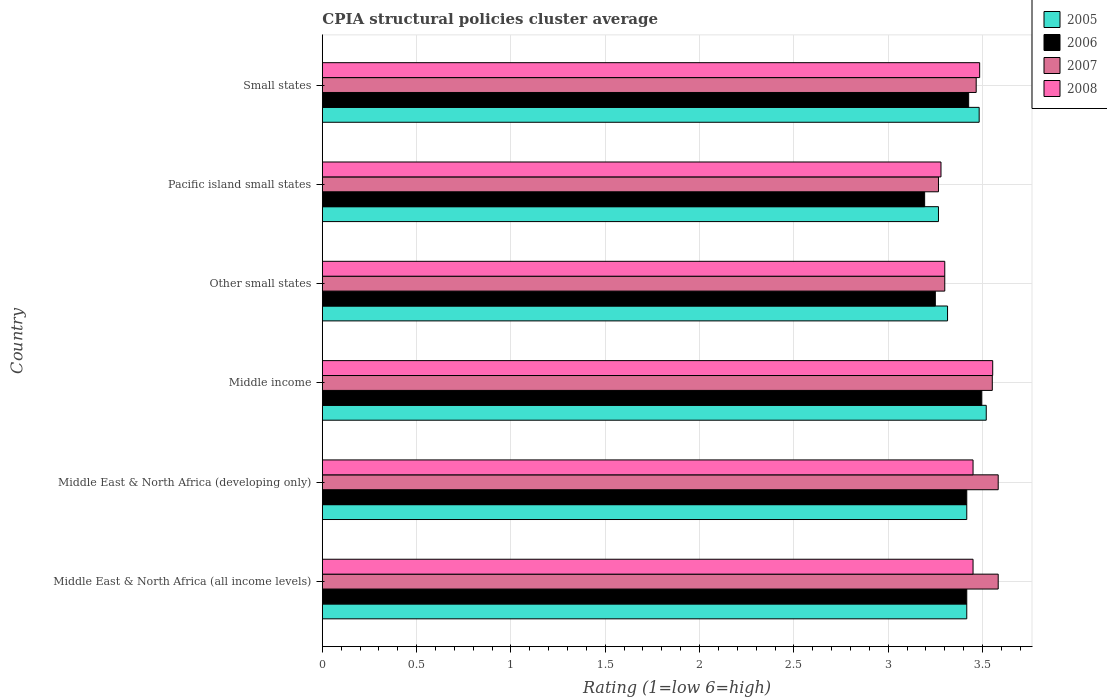How many different coloured bars are there?
Provide a short and direct response. 4. Are the number of bars per tick equal to the number of legend labels?
Keep it short and to the point. Yes. Are the number of bars on each tick of the Y-axis equal?
Your answer should be compact. Yes. How many bars are there on the 6th tick from the top?
Your answer should be compact. 4. How many bars are there on the 4th tick from the bottom?
Provide a succinct answer. 4. What is the CPIA rating in 2005 in Small states?
Your response must be concise. 3.48. Across all countries, what is the maximum CPIA rating in 2008?
Offer a terse response. 3.55. Across all countries, what is the minimum CPIA rating in 2008?
Offer a terse response. 3.28. In which country was the CPIA rating in 2007 maximum?
Your response must be concise. Middle East & North Africa (all income levels). In which country was the CPIA rating in 2008 minimum?
Keep it short and to the point. Pacific island small states. What is the total CPIA rating in 2005 in the graph?
Offer a very short reply. 20.42. What is the difference between the CPIA rating in 2005 in Middle East & North Africa (developing only) and that in Small states?
Keep it short and to the point. -0.07. What is the difference between the CPIA rating in 2006 in Middle East & North Africa (all income levels) and the CPIA rating in 2005 in Middle East & North Africa (developing only)?
Your answer should be very brief. 0. What is the average CPIA rating in 2005 per country?
Offer a very short reply. 3.4. What is the difference between the CPIA rating in 2006 and CPIA rating in 2005 in Small states?
Give a very brief answer. -0.06. What is the ratio of the CPIA rating in 2005 in Middle East & North Africa (developing only) to that in Small states?
Provide a succinct answer. 0.98. Is the CPIA rating in 2007 in Other small states less than that in Pacific island small states?
Give a very brief answer. No. What is the difference between the highest and the second highest CPIA rating in 2006?
Your answer should be compact. 0.07. What is the difference between the highest and the lowest CPIA rating in 2005?
Provide a succinct answer. 0.25. Is it the case that in every country, the sum of the CPIA rating in 2007 and CPIA rating in 2006 is greater than the sum of CPIA rating in 2005 and CPIA rating in 2008?
Your response must be concise. No. What does the 2nd bar from the top in Middle East & North Africa (all income levels) represents?
Make the answer very short. 2007. How many bars are there?
Offer a terse response. 24. Are all the bars in the graph horizontal?
Your response must be concise. Yes. How many countries are there in the graph?
Your answer should be very brief. 6. Are the values on the major ticks of X-axis written in scientific E-notation?
Give a very brief answer. No. Does the graph contain any zero values?
Your answer should be very brief. No. Does the graph contain grids?
Ensure brevity in your answer.  Yes. Where does the legend appear in the graph?
Offer a terse response. Top right. How many legend labels are there?
Provide a short and direct response. 4. How are the legend labels stacked?
Make the answer very short. Vertical. What is the title of the graph?
Keep it short and to the point. CPIA structural policies cluster average. Does "1974" appear as one of the legend labels in the graph?
Keep it short and to the point. No. What is the Rating (1=low 6=high) of 2005 in Middle East & North Africa (all income levels)?
Provide a succinct answer. 3.42. What is the Rating (1=low 6=high) of 2006 in Middle East & North Africa (all income levels)?
Keep it short and to the point. 3.42. What is the Rating (1=low 6=high) in 2007 in Middle East & North Africa (all income levels)?
Your response must be concise. 3.58. What is the Rating (1=low 6=high) of 2008 in Middle East & North Africa (all income levels)?
Provide a short and direct response. 3.45. What is the Rating (1=low 6=high) of 2005 in Middle East & North Africa (developing only)?
Provide a short and direct response. 3.42. What is the Rating (1=low 6=high) in 2006 in Middle East & North Africa (developing only)?
Keep it short and to the point. 3.42. What is the Rating (1=low 6=high) in 2007 in Middle East & North Africa (developing only)?
Your answer should be compact. 3.58. What is the Rating (1=low 6=high) of 2008 in Middle East & North Africa (developing only)?
Make the answer very short. 3.45. What is the Rating (1=low 6=high) in 2005 in Middle income?
Provide a short and direct response. 3.52. What is the Rating (1=low 6=high) of 2006 in Middle income?
Offer a very short reply. 3.5. What is the Rating (1=low 6=high) of 2007 in Middle income?
Your answer should be compact. 3.55. What is the Rating (1=low 6=high) of 2008 in Middle income?
Offer a terse response. 3.55. What is the Rating (1=low 6=high) of 2005 in Other small states?
Keep it short and to the point. 3.31. What is the Rating (1=low 6=high) of 2006 in Other small states?
Offer a terse response. 3.25. What is the Rating (1=low 6=high) of 2008 in Other small states?
Offer a very short reply. 3.3. What is the Rating (1=low 6=high) of 2005 in Pacific island small states?
Provide a short and direct response. 3.27. What is the Rating (1=low 6=high) in 2006 in Pacific island small states?
Ensure brevity in your answer.  3.19. What is the Rating (1=low 6=high) of 2007 in Pacific island small states?
Your answer should be compact. 3.27. What is the Rating (1=low 6=high) in 2008 in Pacific island small states?
Provide a short and direct response. 3.28. What is the Rating (1=low 6=high) in 2005 in Small states?
Provide a succinct answer. 3.48. What is the Rating (1=low 6=high) in 2006 in Small states?
Offer a very short reply. 3.43. What is the Rating (1=low 6=high) in 2007 in Small states?
Ensure brevity in your answer.  3.47. What is the Rating (1=low 6=high) in 2008 in Small states?
Ensure brevity in your answer.  3.48. Across all countries, what is the maximum Rating (1=low 6=high) in 2005?
Provide a succinct answer. 3.52. Across all countries, what is the maximum Rating (1=low 6=high) of 2006?
Your answer should be very brief. 3.5. Across all countries, what is the maximum Rating (1=low 6=high) in 2007?
Provide a short and direct response. 3.58. Across all countries, what is the maximum Rating (1=low 6=high) of 2008?
Provide a short and direct response. 3.55. Across all countries, what is the minimum Rating (1=low 6=high) in 2005?
Give a very brief answer. 3.27. Across all countries, what is the minimum Rating (1=low 6=high) of 2006?
Ensure brevity in your answer.  3.19. Across all countries, what is the minimum Rating (1=low 6=high) of 2007?
Offer a terse response. 3.27. Across all countries, what is the minimum Rating (1=low 6=high) in 2008?
Provide a short and direct response. 3.28. What is the total Rating (1=low 6=high) of 2005 in the graph?
Ensure brevity in your answer.  20.42. What is the total Rating (1=low 6=high) in 2006 in the graph?
Your response must be concise. 20.2. What is the total Rating (1=low 6=high) of 2007 in the graph?
Your answer should be compact. 20.75. What is the total Rating (1=low 6=high) of 2008 in the graph?
Give a very brief answer. 20.52. What is the difference between the Rating (1=low 6=high) in 2005 in Middle East & North Africa (all income levels) and that in Middle East & North Africa (developing only)?
Your answer should be very brief. 0. What is the difference between the Rating (1=low 6=high) of 2006 in Middle East & North Africa (all income levels) and that in Middle East & North Africa (developing only)?
Ensure brevity in your answer.  0. What is the difference between the Rating (1=low 6=high) of 2008 in Middle East & North Africa (all income levels) and that in Middle East & North Africa (developing only)?
Offer a terse response. 0. What is the difference between the Rating (1=low 6=high) in 2005 in Middle East & North Africa (all income levels) and that in Middle income?
Provide a succinct answer. -0.1. What is the difference between the Rating (1=low 6=high) in 2006 in Middle East & North Africa (all income levels) and that in Middle income?
Your answer should be compact. -0.08. What is the difference between the Rating (1=low 6=high) of 2007 in Middle East & North Africa (all income levels) and that in Middle income?
Your answer should be very brief. 0.03. What is the difference between the Rating (1=low 6=high) of 2008 in Middle East & North Africa (all income levels) and that in Middle income?
Give a very brief answer. -0.1. What is the difference between the Rating (1=low 6=high) of 2005 in Middle East & North Africa (all income levels) and that in Other small states?
Your answer should be very brief. 0.1. What is the difference between the Rating (1=low 6=high) of 2007 in Middle East & North Africa (all income levels) and that in Other small states?
Provide a short and direct response. 0.28. What is the difference between the Rating (1=low 6=high) in 2005 in Middle East & North Africa (all income levels) and that in Pacific island small states?
Your answer should be very brief. 0.15. What is the difference between the Rating (1=low 6=high) in 2006 in Middle East & North Africa (all income levels) and that in Pacific island small states?
Give a very brief answer. 0.22. What is the difference between the Rating (1=low 6=high) of 2007 in Middle East & North Africa (all income levels) and that in Pacific island small states?
Give a very brief answer. 0.32. What is the difference between the Rating (1=low 6=high) of 2008 in Middle East & North Africa (all income levels) and that in Pacific island small states?
Offer a terse response. 0.17. What is the difference between the Rating (1=low 6=high) of 2005 in Middle East & North Africa (all income levels) and that in Small states?
Provide a short and direct response. -0.07. What is the difference between the Rating (1=low 6=high) of 2006 in Middle East & North Africa (all income levels) and that in Small states?
Ensure brevity in your answer.  -0.01. What is the difference between the Rating (1=low 6=high) of 2007 in Middle East & North Africa (all income levels) and that in Small states?
Your answer should be compact. 0.12. What is the difference between the Rating (1=low 6=high) in 2008 in Middle East & North Africa (all income levels) and that in Small states?
Keep it short and to the point. -0.04. What is the difference between the Rating (1=low 6=high) of 2005 in Middle East & North Africa (developing only) and that in Middle income?
Give a very brief answer. -0.1. What is the difference between the Rating (1=low 6=high) of 2006 in Middle East & North Africa (developing only) and that in Middle income?
Provide a succinct answer. -0.08. What is the difference between the Rating (1=low 6=high) in 2007 in Middle East & North Africa (developing only) and that in Middle income?
Make the answer very short. 0.03. What is the difference between the Rating (1=low 6=high) of 2008 in Middle East & North Africa (developing only) and that in Middle income?
Your response must be concise. -0.1. What is the difference between the Rating (1=low 6=high) of 2005 in Middle East & North Africa (developing only) and that in Other small states?
Offer a very short reply. 0.1. What is the difference between the Rating (1=low 6=high) in 2007 in Middle East & North Africa (developing only) and that in Other small states?
Offer a very short reply. 0.28. What is the difference between the Rating (1=low 6=high) in 2008 in Middle East & North Africa (developing only) and that in Other small states?
Your answer should be compact. 0.15. What is the difference between the Rating (1=low 6=high) in 2005 in Middle East & North Africa (developing only) and that in Pacific island small states?
Keep it short and to the point. 0.15. What is the difference between the Rating (1=low 6=high) of 2006 in Middle East & North Africa (developing only) and that in Pacific island small states?
Provide a short and direct response. 0.22. What is the difference between the Rating (1=low 6=high) in 2007 in Middle East & North Africa (developing only) and that in Pacific island small states?
Your answer should be very brief. 0.32. What is the difference between the Rating (1=low 6=high) in 2008 in Middle East & North Africa (developing only) and that in Pacific island small states?
Offer a very short reply. 0.17. What is the difference between the Rating (1=low 6=high) of 2005 in Middle East & North Africa (developing only) and that in Small states?
Keep it short and to the point. -0.07. What is the difference between the Rating (1=low 6=high) of 2006 in Middle East & North Africa (developing only) and that in Small states?
Provide a succinct answer. -0.01. What is the difference between the Rating (1=low 6=high) of 2007 in Middle East & North Africa (developing only) and that in Small states?
Ensure brevity in your answer.  0.12. What is the difference between the Rating (1=low 6=high) of 2008 in Middle East & North Africa (developing only) and that in Small states?
Your response must be concise. -0.04. What is the difference between the Rating (1=low 6=high) of 2005 in Middle income and that in Other small states?
Your response must be concise. 0.21. What is the difference between the Rating (1=low 6=high) in 2006 in Middle income and that in Other small states?
Give a very brief answer. 0.25. What is the difference between the Rating (1=low 6=high) of 2007 in Middle income and that in Other small states?
Offer a terse response. 0.25. What is the difference between the Rating (1=low 6=high) in 2008 in Middle income and that in Other small states?
Offer a very short reply. 0.25. What is the difference between the Rating (1=low 6=high) of 2005 in Middle income and that in Pacific island small states?
Your response must be concise. 0.25. What is the difference between the Rating (1=low 6=high) in 2006 in Middle income and that in Pacific island small states?
Give a very brief answer. 0.3. What is the difference between the Rating (1=low 6=high) of 2007 in Middle income and that in Pacific island small states?
Keep it short and to the point. 0.29. What is the difference between the Rating (1=low 6=high) in 2008 in Middle income and that in Pacific island small states?
Your response must be concise. 0.27. What is the difference between the Rating (1=low 6=high) of 2005 in Middle income and that in Small states?
Give a very brief answer. 0.04. What is the difference between the Rating (1=low 6=high) of 2006 in Middle income and that in Small states?
Offer a very short reply. 0.07. What is the difference between the Rating (1=low 6=high) in 2007 in Middle income and that in Small states?
Give a very brief answer. 0.09. What is the difference between the Rating (1=low 6=high) of 2008 in Middle income and that in Small states?
Make the answer very short. 0.07. What is the difference between the Rating (1=low 6=high) of 2005 in Other small states and that in Pacific island small states?
Your response must be concise. 0.05. What is the difference between the Rating (1=low 6=high) of 2006 in Other small states and that in Pacific island small states?
Keep it short and to the point. 0.06. What is the difference between the Rating (1=low 6=high) of 2005 in Other small states and that in Small states?
Keep it short and to the point. -0.17. What is the difference between the Rating (1=low 6=high) in 2006 in Other small states and that in Small states?
Give a very brief answer. -0.18. What is the difference between the Rating (1=low 6=high) of 2007 in Other small states and that in Small states?
Give a very brief answer. -0.17. What is the difference between the Rating (1=low 6=high) of 2008 in Other small states and that in Small states?
Provide a succinct answer. -0.18. What is the difference between the Rating (1=low 6=high) of 2005 in Pacific island small states and that in Small states?
Provide a succinct answer. -0.22. What is the difference between the Rating (1=low 6=high) of 2006 in Pacific island small states and that in Small states?
Provide a succinct answer. -0.23. What is the difference between the Rating (1=low 6=high) of 2008 in Pacific island small states and that in Small states?
Keep it short and to the point. -0.2. What is the difference between the Rating (1=low 6=high) of 2005 in Middle East & North Africa (all income levels) and the Rating (1=low 6=high) of 2006 in Middle East & North Africa (developing only)?
Ensure brevity in your answer.  0. What is the difference between the Rating (1=low 6=high) in 2005 in Middle East & North Africa (all income levels) and the Rating (1=low 6=high) in 2008 in Middle East & North Africa (developing only)?
Offer a terse response. -0.03. What is the difference between the Rating (1=low 6=high) of 2006 in Middle East & North Africa (all income levels) and the Rating (1=low 6=high) of 2007 in Middle East & North Africa (developing only)?
Your response must be concise. -0.17. What is the difference between the Rating (1=low 6=high) of 2006 in Middle East & North Africa (all income levels) and the Rating (1=low 6=high) of 2008 in Middle East & North Africa (developing only)?
Provide a succinct answer. -0.03. What is the difference between the Rating (1=low 6=high) of 2007 in Middle East & North Africa (all income levels) and the Rating (1=low 6=high) of 2008 in Middle East & North Africa (developing only)?
Keep it short and to the point. 0.13. What is the difference between the Rating (1=low 6=high) of 2005 in Middle East & North Africa (all income levels) and the Rating (1=low 6=high) of 2006 in Middle income?
Your answer should be compact. -0.08. What is the difference between the Rating (1=low 6=high) of 2005 in Middle East & North Africa (all income levels) and the Rating (1=low 6=high) of 2007 in Middle income?
Your response must be concise. -0.14. What is the difference between the Rating (1=low 6=high) of 2005 in Middle East & North Africa (all income levels) and the Rating (1=low 6=high) of 2008 in Middle income?
Give a very brief answer. -0.14. What is the difference between the Rating (1=low 6=high) of 2006 in Middle East & North Africa (all income levels) and the Rating (1=low 6=high) of 2007 in Middle income?
Give a very brief answer. -0.14. What is the difference between the Rating (1=low 6=high) in 2006 in Middle East & North Africa (all income levels) and the Rating (1=low 6=high) in 2008 in Middle income?
Provide a short and direct response. -0.14. What is the difference between the Rating (1=low 6=high) of 2007 in Middle East & North Africa (all income levels) and the Rating (1=low 6=high) of 2008 in Middle income?
Provide a short and direct response. 0.03. What is the difference between the Rating (1=low 6=high) of 2005 in Middle East & North Africa (all income levels) and the Rating (1=low 6=high) of 2007 in Other small states?
Provide a short and direct response. 0.12. What is the difference between the Rating (1=low 6=high) of 2005 in Middle East & North Africa (all income levels) and the Rating (1=low 6=high) of 2008 in Other small states?
Your answer should be compact. 0.12. What is the difference between the Rating (1=low 6=high) in 2006 in Middle East & North Africa (all income levels) and the Rating (1=low 6=high) in 2007 in Other small states?
Keep it short and to the point. 0.12. What is the difference between the Rating (1=low 6=high) of 2006 in Middle East & North Africa (all income levels) and the Rating (1=low 6=high) of 2008 in Other small states?
Keep it short and to the point. 0.12. What is the difference between the Rating (1=low 6=high) of 2007 in Middle East & North Africa (all income levels) and the Rating (1=low 6=high) of 2008 in Other small states?
Provide a short and direct response. 0.28. What is the difference between the Rating (1=low 6=high) in 2005 in Middle East & North Africa (all income levels) and the Rating (1=low 6=high) in 2006 in Pacific island small states?
Provide a short and direct response. 0.22. What is the difference between the Rating (1=low 6=high) of 2005 in Middle East & North Africa (all income levels) and the Rating (1=low 6=high) of 2007 in Pacific island small states?
Give a very brief answer. 0.15. What is the difference between the Rating (1=low 6=high) in 2005 in Middle East & North Africa (all income levels) and the Rating (1=low 6=high) in 2008 in Pacific island small states?
Provide a short and direct response. 0.14. What is the difference between the Rating (1=low 6=high) in 2006 in Middle East & North Africa (all income levels) and the Rating (1=low 6=high) in 2008 in Pacific island small states?
Your answer should be very brief. 0.14. What is the difference between the Rating (1=low 6=high) of 2007 in Middle East & North Africa (all income levels) and the Rating (1=low 6=high) of 2008 in Pacific island small states?
Give a very brief answer. 0.3. What is the difference between the Rating (1=low 6=high) in 2005 in Middle East & North Africa (all income levels) and the Rating (1=low 6=high) in 2006 in Small states?
Offer a terse response. -0.01. What is the difference between the Rating (1=low 6=high) in 2005 in Middle East & North Africa (all income levels) and the Rating (1=low 6=high) in 2007 in Small states?
Provide a short and direct response. -0.05. What is the difference between the Rating (1=low 6=high) of 2005 in Middle East & North Africa (all income levels) and the Rating (1=low 6=high) of 2008 in Small states?
Keep it short and to the point. -0.07. What is the difference between the Rating (1=low 6=high) of 2006 in Middle East & North Africa (all income levels) and the Rating (1=low 6=high) of 2008 in Small states?
Ensure brevity in your answer.  -0.07. What is the difference between the Rating (1=low 6=high) in 2007 in Middle East & North Africa (all income levels) and the Rating (1=low 6=high) in 2008 in Small states?
Give a very brief answer. 0.1. What is the difference between the Rating (1=low 6=high) of 2005 in Middle East & North Africa (developing only) and the Rating (1=low 6=high) of 2006 in Middle income?
Ensure brevity in your answer.  -0.08. What is the difference between the Rating (1=low 6=high) in 2005 in Middle East & North Africa (developing only) and the Rating (1=low 6=high) in 2007 in Middle income?
Give a very brief answer. -0.14. What is the difference between the Rating (1=low 6=high) of 2005 in Middle East & North Africa (developing only) and the Rating (1=low 6=high) of 2008 in Middle income?
Give a very brief answer. -0.14. What is the difference between the Rating (1=low 6=high) in 2006 in Middle East & North Africa (developing only) and the Rating (1=low 6=high) in 2007 in Middle income?
Offer a terse response. -0.14. What is the difference between the Rating (1=low 6=high) of 2006 in Middle East & North Africa (developing only) and the Rating (1=low 6=high) of 2008 in Middle income?
Offer a terse response. -0.14. What is the difference between the Rating (1=low 6=high) of 2007 in Middle East & North Africa (developing only) and the Rating (1=low 6=high) of 2008 in Middle income?
Ensure brevity in your answer.  0.03. What is the difference between the Rating (1=low 6=high) of 2005 in Middle East & North Africa (developing only) and the Rating (1=low 6=high) of 2006 in Other small states?
Provide a succinct answer. 0.17. What is the difference between the Rating (1=low 6=high) of 2005 in Middle East & North Africa (developing only) and the Rating (1=low 6=high) of 2007 in Other small states?
Your answer should be compact. 0.12. What is the difference between the Rating (1=low 6=high) of 2005 in Middle East & North Africa (developing only) and the Rating (1=low 6=high) of 2008 in Other small states?
Offer a terse response. 0.12. What is the difference between the Rating (1=low 6=high) of 2006 in Middle East & North Africa (developing only) and the Rating (1=low 6=high) of 2007 in Other small states?
Provide a succinct answer. 0.12. What is the difference between the Rating (1=low 6=high) of 2006 in Middle East & North Africa (developing only) and the Rating (1=low 6=high) of 2008 in Other small states?
Your answer should be very brief. 0.12. What is the difference between the Rating (1=low 6=high) in 2007 in Middle East & North Africa (developing only) and the Rating (1=low 6=high) in 2008 in Other small states?
Your answer should be very brief. 0.28. What is the difference between the Rating (1=low 6=high) of 2005 in Middle East & North Africa (developing only) and the Rating (1=low 6=high) of 2006 in Pacific island small states?
Ensure brevity in your answer.  0.22. What is the difference between the Rating (1=low 6=high) of 2005 in Middle East & North Africa (developing only) and the Rating (1=low 6=high) of 2007 in Pacific island small states?
Make the answer very short. 0.15. What is the difference between the Rating (1=low 6=high) of 2005 in Middle East & North Africa (developing only) and the Rating (1=low 6=high) of 2008 in Pacific island small states?
Your answer should be very brief. 0.14. What is the difference between the Rating (1=low 6=high) of 2006 in Middle East & North Africa (developing only) and the Rating (1=low 6=high) of 2008 in Pacific island small states?
Keep it short and to the point. 0.14. What is the difference between the Rating (1=low 6=high) in 2007 in Middle East & North Africa (developing only) and the Rating (1=low 6=high) in 2008 in Pacific island small states?
Your response must be concise. 0.3. What is the difference between the Rating (1=low 6=high) in 2005 in Middle East & North Africa (developing only) and the Rating (1=low 6=high) in 2006 in Small states?
Offer a very short reply. -0.01. What is the difference between the Rating (1=low 6=high) of 2005 in Middle East & North Africa (developing only) and the Rating (1=low 6=high) of 2007 in Small states?
Your response must be concise. -0.05. What is the difference between the Rating (1=low 6=high) of 2005 in Middle East & North Africa (developing only) and the Rating (1=low 6=high) of 2008 in Small states?
Provide a succinct answer. -0.07. What is the difference between the Rating (1=low 6=high) in 2006 in Middle East & North Africa (developing only) and the Rating (1=low 6=high) in 2008 in Small states?
Your answer should be compact. -0.07. What is the difference between the Rating (1=low 6=high) of 2007 in Middle East & North Africa (developing only) and the Rating (1=low 6=high) of 2008 in Small states?
Provide a short and direct response. 0.1. What is the difference between the Rating (1=low 6=high) of 2005 in Middle income and the Rating (1=low 6=high) of 2006 in Other small states?
Provide a short and direct response. 0.27. What is the difference between the Rating (1=low 6=high) in 2005 in Middle income and the Rating (1=low 6=high) in 2007 in Other small states?
Your answer should be very brief. 0.22. What is the difference between the Rating (1=low 6=high) in 2005 in Middle income and the Rating (1=low 6=high) in 2008 in Other small states?
Provide a succinct answer. 0.22. What is the difference between the Rating (1=low 6=high) in 2006 in Middle income and the Rating (1=low 6=high) in 2007 in Other small states?
Ensure brevity in your answer.  0.2. What is the difference between the Rating (1=low 6=high) in 2006 in Middle income and the Rating (1=low 6=high) in 2008 in Other small states?
Your answer should be compact. 0.2. What is the difference between the Rating (1=low 6=high) in 2007 in Middle income and the Rating (1=low 6=high) in 2008 in Other small states?
Give a very brief answer. 0.25. What is the difference between the Rating (1=low 6=high) in 2005 in Middle income and the Rating (1=low 6=high) in 2006 in Pacific island small states?
Offer a terse response. 0.33. What is the difference between the Rating (1=low 6=high) of 2005 in Middle income and the Rating (1=low 6=high) of 2007 in Pacific island small states?
Ensure brevity in your answer.  0.25. What is the difference between the Rating (1=low 6=high) of 2005 in Middle income and the Rating (1=low 6=high) of 2008 in Pacific island small states?
Make the answer very short. 0.24. What is the difference between the Rating (1=low 6=high) in 2006 in Middle income and the Rating (1=low 6=high) in 2007 in Pacific island small states?
Your answer should be compact. 0.23. What is the difference between the Rating (1=low 6=high) in 2006 in Middle income and the Rating (1=low 6=high) in 2008 in Pacific island small states?
Offer a very short reply. 0.22. What is the difference between the Rating (1=low 6=high) of 2007 in Middle income and the Rating (1=low 6=high) of 2008 in Pacific island small states?
Offer a very short reply. 0.27. What is the difference between the Rating (1=low 6=high) of 2005 in Middle income and the Rating (1=low 6=high) of 2006 in Small states?
Offer a terse response. 0.09. What is the difference between the Rating (1=low 6=high) in 2005 in Middle income and the Rating (1=low 6=high) in 2007 in Small states?
Your answer should be compact. 0.05. What is the difference between the Rating (1=low 6=high) of 2005 in Middle income and the Rating (1=low 6=high) of 2008 in Small states?
Your answer should be very brief. 0.04. What is the difference between the Rating (1=low 6=high) in 2006 in Middle income and the Rating (1=low 6=high) in 2007 in Small states?
Your answer should be very brief. 0.03. What is the difference between the Rating (1=low 6=high) of 2006 in Middle income and the Rating (1=low 6=high) of 2008 in Small states?
Your response must be concise. 0.01. What is the difference between the Rating (1=low 6=high) in 2007 in Middle income and the Rating (1=low 6=high) in 2008 in Small states?
Provide a short and direct response. 0.07. What is the difference between the Rating (1=low 6=high) in 2005 in Other small states and the Rating (1=low 6=high) in 2006 in Pacific island small states?
Give a very brief answer. 0.12. What is the difference between the Rating (1=low 6=high) in 2005 in Other small states and the Rating (1=low 6=high) in 2007 in Pacific island small states?
Your answer should be compact. 0.05. What is the difference between the Rating (1=low 6=high) of 2005 in Other small states and the Rating (1=low 6=high) of 2008 in Pacific island small states?
Provide a short and direct response. 0.03. What is the difference between the Rating (1=low 6=high) in 2006 in Other small states and the Rating (1=low 6=high) in 2007 in Pacific island small states?
Give a very brief answer. -0.02. What is the difference between the Rating (1=low 6=high) of 2006 in Other small states and the Rating (1=low 6=high) of 2008 in Pacific island small states?
Give a very brief answer. -0.03. What is the difference between the Rating (1=low 6=high) in 2007 in Other small states and the Rating (1=low 6=high) in 2008 in Pacific island small states?
Your answer should be very brief. 0.02. What is the difference between the Rating (1=low 6=high) of 2005 in Other small states and the Rating (1=low 6=high) of 2006 in Small states?
Keep it short and to the point. -0.11. What is the difference between the Rating (1=low 6=high) in 2005 in Other small states and the Rating (1=low 6=high) in 2007 in Small states?
Your response must be concise. -0.15. What is the difference between the Rating (1=low 6=high) in 2005 in Other small states and the Rating (1=low 6=high) in 2008 in Small states?
Your answer should be very brief. -0.17. What is the difference between the Rating (1=low 6=high) of 2006 in Other small states and the Rating (1=low 6=high) of 2007 in Small states?
Offer a very short reply. -0.22. What is the difference between the Rating (1=low 6=high) of 2006 in Other small states and the Rating (1=low 6=high) of 2008 in Small states?
Offer a very short reply. -0.23. What is the difference between the Rating (1=low 6=high) of 2007 in Other small states and the Rating (1=low 6=high) of 2008 in Small states?
Offer a very short reply. -0.18. What is the difference between the Rating (1=low 6=high) of 2005 in Pacific island small states and the Rating (1=low 6=high) of 2006 in Small states?
Your answer should be very brief. -0.16. What is the difference between the Rating (1=low 6=high) in 2005 in Pacific island small states and the Rating (1=low 6=high) in 2007 in Small states?
Provide a short and direct response. -0.2. What is the difference between the Rating (1=low 6=high) in 2005 in Pacific island small states and the Rating (1=low 6=high) in 2008 in Small states?
Your answer should be compact. -0.22. What is the difference between the Rating (1=low 6=high) of 2006 in Pacific island small states and the Rating (1=low 6=high) of 2007 in Small states?
Your answer should be very brief. -0.27. What is the difference between the Rating (1=low 6=high) in 2006 in Pacific island small states and the Rating (1=low 6=high) in 2008 in Small states?
Your answer should be compact. -0.29. What is the difference between the Rating (1=low 6=high) in 2007 in Pacific island small states and the Rating (1=low 6=high) in 2008 in Small states?
Keep it short and to the point. -0.22. What is the average Rating (1=low 6=high) in 2005 per country?
Your answer should be compact. 3.4. What is the average Rating (1=low 6=high) of 2006 per country?
Provide a short and direct response. 3.37. What is the average Rating (1=low 6=high) in 2007 per country?
Offer a very short reply. 3.46. What is the average Rating (1=low 6=high) in 2008 per country?
Offer a terse response. 3.42. What is the difference between the Rating (1=low 6=high) in 2005 and Rating (1=low 6=high) in 2008 in Middle East & North Africa (all income levels)?
Your response must be concise. -0.03. What is the difference between the Rating (1=low 6=high) in 2006 and Rating (1=low 6=high) in 2008 in Middle East & North Africa (all income levels)?
Offer a terse response. -0.03. What is the difference between the Rating (1=low 6=high) of 2007 and Rating (1=low 6=high) of 2008 in Middle East & North Africa (all income levels)?
Ensure brevity in your answer.  0.13. What is the difference between the Rating (1=low 6=high) in 2005 and Rating (1=low 6=high) in 2007 in Middle East & North Africa (developing only)?
Provide a succinct answer. -0.17. What is the difference between the Rating (1=low 6=high) of 2005 and Rating (1=low 6=high) of 2008 in Middle East & North Africa (developing only)?
Make the answer very short. -0.03. What is the difference between the Rating (1=low 6=high) in 2006 and Rating (1=low 6=high) in 2007 in Middle East & North Africa (developing only)?
Provide a short and direct response. -0.17. What is the difference between the Rating (1=low 6=high) in 2006 and Rating (1=low 6=high) in 2008 in Middle East & North Africa (developing only)?
Keep it short and to the point. -0.03. What is the difference between the Rating (1=low 6=high) in 2007 and Rating (1=low 6=high) in 2008 in Middle East & North Africa (developing only)?
Ensure brevity in your answer.  0.13. What is the difference between the Rating (1=low 6=high) in 2005 and Rating (1=low 6=high) in 2006 in Middle income?
Make the answer very short. 0.02. What is the difference between the Rating (1=low 6=high) in 2005 and Rating (1=low 6=high) in 2007 in Middle income?
Provide a short and direct response. -0.03. What is the difference between the Rating (1=low 6=high) in 2005 and Rating (1=low 6=high) in 2008 in Middle income?
Provide a short and direct response. -0.03. What is the difference between the Rating (1=low 6=high) in 2006 and Rating (1=low 6=high) in 2007 in Middle income?
Your answer should be compact. -0.06. What is the difference between the Rating (1=low 6=high) of 2006 and Rating (1=low 6=high) of 2008 in Middle income?
Your answer should be very brief. -0.06. What is the difference between the Rating (1=low 6=high) of 2007 and Rating (1=low 6=high) of 2008 in Middle income?
Give a very brief answer. -0. What is the difference between the Rating (1=low 6=high) in 2005 and Rating (1=low 6=high) in 2006 in Other small states?
Your answer should be very brief. 0.06. What is the difference between the Rating (1=low 6=high) of 2005 and Rating (1=low 6=high) of 2007 in Other small states?
Ensure brevity in your answer.  0.01. What is the difference between the Rating (1=low 6=high) of 2005 and Rating (1=low 6=high) of 2008 in Other small states?
Ensure brevity in your answer.  0.01. What is the difference between the Rating (1=low 6=high) of 2006 and Rating (1=low 6=high) of 2007 in Other small states?
Ensure brevity in your answer.  -0.05. What is the difference between the Rating (1=low 6=high) in 2007 and Rating (1=low 6=high) in 2008 in Other small states?
Your answer should be compact. 0. What is the difference between the Rating (1=low 6=high) of 2005 and Rating (1=low 6=high) of 2006 in Pacific island small states?
Ensure brevity in your answer.  0.07. What is the difference between the Rating (1=low 6=high) of 2005 and Rating (1=low 6=high) of 2008 in Pacific island small states?
Your answer should be compact. -0.01. What is the difference between the Rating (1=low 6=high) in 2006 and Rating (1=low 6=high) in 2007 in Pacific island small states?
Ensure brevity in your answer.  -0.07. What is the difference between the Rating (1=low 6=high) of 2006 and Rating (1=low 6=high) of 2008 in Pacific island small states?
Provide a short and direct response. -0.09. What is the difference between the Rating (1=low 6=high) of 2007 and Rating (1=low 6=high) of 2008 in Pacific island small states?
Your answer should be compact. -0.01. What is the difference between the Rating (1=low 6=high) in 2005 and Rating (1=low 6=high) in 2006 in Small states?
Make the answer very short. 0.06. What is the difference between the Rating (1=low 6=high) in 2005 and Rating (1=low 6=high) in 2007 in Small states?
Your response must be concise. 0.02. What is the difference between the Rating (1=low 6=high) of 2005 and Rating (1=low 6=high) of 2008 in Small states?
Offer a terse response. -0. What is the difference between the Rating (1=low 6=high) of 2006 and Rating (1=low 6=high) of 2007 in Small states?
Ensure brevity in your answer.  -0.04. What is the difference between the Rating (1=low 6=high) in 2006 and Rating (1=low 6=high) in 2008 in Small states?
Provide a succinct answer. -0.06. What is the difference between the Rating (1=low 6=high) in 2007 and Rating (1=low 6=high) in 2008 in Small states?
Keep it short and to the point. -0.02. What is the ratio of the Rating (1=low 6=high) in 2005 in Middle East & North Africa (all income levels) to that in Middle East & North Africa (developing only)?
Provide a succinct answer. 1. What is the ratio of the Rating (1=low 6=high) of 2008 in Middle East & North Africa (all income levels) to that in Middle East & North Africa (developing only)?
Keep it short and to the point. 1. What is the ratio of the Rating (1=low 6=high) of 2005 in Middle East & North Africa (all income levels) to that in Middle income?
Your response must be concise. 0.97. What is the ratio of the Rating (1=low 6=high) of 2006 in Middle East & North Africa (all income levels) to that in Middle income?
Offer a terse response. 0.98. What is the ratio of the Rating (1=low 6=high) of 2007 in Middle East & North Africa (all income levels) to that in Middle income?
Your response must be concise. 1.01. What is the ratio of the Rating (1=low 6=high) in 2008 in Middle East & North Africa (all income levels) to that in Middle income?
Your response must be concise. 0.97. What is the ratio of the Rating (1=low 6=high) in 2005 in Middle East & North Africa (all income levels) to that in Other small states?
Offer a very short reply. 1.03. What is the ratio of the Rating (1=low 6=high) of 2006 in Middle East & North Africa (all income levels) to that in Other small states?
Offer a very short reply. 1.05. What is the ratio of the Rating (1=low 6=high) of 2007 in Middle East & North Africa (all income levels) to that in Other small states?
Make the answer very short. 1.09. What is the ratio of the Rating (1=low 6=high) of 2008 in Middle East & North Africa (all income levels) to that in Other small states?
Give a very brief answer. 1.05. What is the ratio of the Rating (1=low 6=high) in 2005 in Middle East & North Africa (all income levels) to that in Pacific island small states?
Provide a succinct answer. 1.05. What is the ratio of the Rating (1=low 6=high) of 2006 in Middle East & North Africa (all income levels) to that in Pacific island small states?
Ensure brevity in your answer.  1.07. What is the ratio of the Rating (1=low 6=high) in 2007 in Middle East & North Africa (all income levels) to that in Pacific island small states?
Offer a very short reply. 1.1. What is the ratio of the Rating (1=low 6=high) of 2008 in Middle East & North Africa (all income levels) to that in Pacific island small states?
Make the answer very short. 1.05. What is the ratio of the Rating (1=low 6=high) of 2005 in Middle East & North Africa (all income levels) to that in Small states?
Provide a short and direct response. 0.98. What is the ratio of the Rating (1=low 6=high) in 2007 in Middle East & North Africa (all income levels) to that in Small states?
Provide a succinct answer. 1.03. What is the ratio of the Rating (1=low 6=high) of 2008 in Middle East & North Africa (all income levels) to that in Small states?
Offer a terse response. 0.99. What is the ratio of the Rating (1=low 6=high) in 2005 in Middle East & North Africa (developing only) to that in Middle income?
Your answer should be compact. 0.97. What is the ratio of the Rating (1=low 6=high) of 2006 in Middle East & North Africa (developing only) to that in Middle income?
Provide a short and direct response. 0.98. What is the ratio of the Rating (1=low 6=high) in 2007 in Middle East & North Africa (developing only) to that in Middle income?
Keep it short and to the point. 1.01. What is the ratio of the Rating (1=low 6=high) of 2008 in Middle East & North Africa (developing only) to that in Middle income?
Keep it short and to the point. 0.97. What is the ratio of the Rating (1=low 6=high) of 2005 in Middle East & North Africa (developing only) to that in Other small states?
Offer a terse response. 1.03. What is the ratio of the Rating (1=low 6=high) in 2006 in Middle East & North Africa (developing only) to that in Other small states?
Provide a succinct answer. 1.05. What is the ratio of the Rating (1=low 6=high) in 2007 in Middle East & North Africa (developing only) to that in Other small states?
Your answer should be very brief. 1.09. What is the ratio of the Rating (1=low 6=high) in 2008 in Middle East & North Africa (developing only) to that in Other small states?
Offer a very short reply. 1.05. What is the ratio of the Rating (1=low 6=high) in 2005 in Middle East & North Africa (developing only) to that in Pacific island small states?
Ensure brevity in your answer.  1.05. What is the ratio of the Rating (1=low 6=high) of 2006 in Middle East & North Africa (developing only) to that in Pacific island small states?
Provide a short and direct response. 1.07. What is the ratio of the Rating (1=low 6=high) of 2007 in Middle East & North Africa (developing only) to that in Pacific island small states?
Offer a very short reply. 1.1. What is the ratio of the Rating (1=low 6=high) in 2008 in Middle East & North Africa (developing only) to that in Pacific island small states?
Keep it short and to the point. 1.05. What is the ratio of the Rating (1=low 6=high) in 2005 in Middle East & North Africa (developing only) to that in Small states?
Keep it short and to the point. 0.98. What is the ratio of the Rating (1=low 6=high) of 2006 in Middle East & North Africa (developing only) to that in Small states?
Keep it short and to the point. 1. What is the ratio of the Rating (1=low 6=high) in 2007 in Middle East & North Africa (developing only) to that in Small states?
Ensure brevity in your answer.  1.03. What is the ratio of the Rating (1=low 6=high) in 2008 in Middle East & North Africa (developing only) to that in Small states?
Ensure brevity in your answer.  0.99. What is the ratio of the Rating (1=low 6=high) in 2005 in Middle income to that in Other small states?
Your answer should be compact. 1.06. What is the ratio of the Rating (1=low 6=high) of 2006 in Middle income to that in Other small states?
Provide a succinct answer. 1.08. What is the ratio of the Rating (1=low 6=high) in 2007 in Middle income to that in Other small states?
Your answer should be compact. 1.08. What is the ratio of the Rating (1=low 6=high) of 2008 in Middle income to that in Other small states?
Ensure brevity in your answer.  1.08. What is the ratio of the Rating (1=low 6=high) of 2005 in Middle income to that in Pacific island small states?
Offer a terse response. 1.08. What is the ratio of the Rating (1=low 6=high) in 2006 in Middle income to that in Pacific island small states?
Provide a short and direct response. 1.09. What is the ratio of the Rating (1=low 6=high) of 2007 in Middle income to that in Pacific island small states?
Offer a terse response. 1.09. What is the ratio of the Rating (1=low 6=high) in 2008 in Middle income to that in Pacific island small states?
Provide a short and direct response. 1.08. What is the ratio of the Rating (1=low 6=high) of 2005 in Middle income to that in Small states?
Make the answer very short. 1.01. What is the ratio of the Rating (1=low 6=high) in 2006 in Middle income to that in Small states?
Your answer should be very brief. 1.02. What is the ratio of the Rating (1=low 6=high) in 2007 in Middle income to that in Small states?
Make the answer very short. 1.02. What is the ratio of the Rating (1=low 6=high) of 2008 in Middle income to that in Small states?
Your answer should be compact. 1.02. What is the ratio of the Rating (1=low 6=high) of 2005 in Other small states to that in Pacific island small states?
Your answer should be compact. 1.01. What is the ratio of the Rating (1=low 6=high) in 2006 in Other small states to that in Pacific island small states?
Provide a succinct answer. 1.02. What is the ratio of the Rating (1=low 6=high) in 2007 in Other small states to that in Pacific island small states?
Give a very brief answer. 1.01. What is the ratio of the Rating (1=low 6=high) of 2008 in Other small states to that in Pacific island small states?
Your response must be concise. 1.01. What is the ratio of the Rating (1=low 6=high) of 2005 in Other small states to that in Small states?
Ensure brevity in your answer.  0.95. What is the ratio of the Rating (1=low 6=high) of 2006 in Other small states to that in Small states?
Your answer should be compact. 0.95. What is the ratio of the Rating (1=low 6=high) of 2007 in Other small states to that in Small states?
Keep it short and to the point. 0.95. What is the ratio of the Rating (1=low 6=high) of 2008 in Other small states to that in Small states?
Your answer should be very brief. 0.95. What is the ratio of the Rating (1=low 6=high) in 2005 in Pacific island small states to that in Small states?
Provide a short and direct response. 0.94. What is the ratio of the Rating (1=low 6=high) in 2006 in Pacific island small states to that in Small states?
Your answer should be very brief. 0.93. What is the ratio of the Rating (1=low 6=high) in 2007 in Pacific island small states to that in Small states?
Keep it short and to the point. 0.94. What is the ratio of the Rating (1=low 6=high) of 2008 in Pacific island small states to that in Small states?
Provide a short and direct response. 0.94. What is the difference between the highest and the second highest Rating (1=low 6=high) of 2005?
Keep it short and to the point. 0.04. What is the difference between the highest and the second highest Rating (1=low 6=high) of 2006?
Give a very brief answer. 0.07. What is the difference between the highest and the second highest Rating (1=low 6=high) in 2008?
Your response must be concise. 0.07. What is the difference between the highest and the lowest Rating (1=low 6=high) of 2005?
Your response must be concise. 0.25. What is the difference between the highest and the lowest Rating (1=low 6=high) in 2006?
Make the answer very short. 0.3. What is the difference between the highest and the lowest Rating (1=low 6=high) in 2007?
Your response must be concise. 0.32. What is the difference between the highest and the lowest Rating (1=low 6=high) of 2008?
Provide a succinct answer. 0.27. 